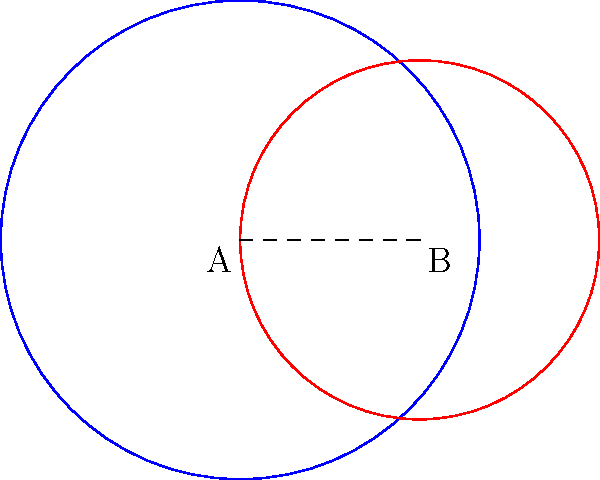Two spotlights are positioned on a stage, represented by circles A and B in the diagram. Spotlight A has a radius of 4 meters, and spotlight B has a radius of 3 meters. The centers of the spotlights are 3 meters apart. What is the area of the overlapping region where both spotlights illuminate the stage? Round your answer to two decimal places. To find the area of overlap between two circles, we need to use the formula for the area of intersection:

1) First, calculate the distance $d$ between the centers:
   $d = 3$ meters (given)

2) Use the formula for the area of intersection:
   $A = r_1^2 \arccos(\frac{d^2 + r_1^2 - r_2^2}{2dr_1}) + r_2^2 \arccos(\frac{d^2 + r_2^2 - r_1^2}{2dr_2}) - \frac{1}{2}\sqrt{(-d+r_1+r_2)(d+r_1-r_2)(d-r_1+r_2)(d+r_1+r_2)}$

   Where $r_1 = 4$ and $r_2 = 3$

3) Substitute the values:
   $A = 4^2 \arccos(\frac{3^2 + 4^2 - 3^2}{2 \cdot 3 \cdot 4}) + 3^2 \arccos(\frac{3^2 + 3^2 - 4^2}{2 \cdot 3 \cdot 3}) - \frac{1}{2}\sqrt{(-3+4+3)(3+4-3)(3-4+3)(3+4+3)}$

4) Calculate:
   $A \approx 16 \cdot 0.6435 + 9 \cdot 1.2490 - \frac{1}{2} \cdot 5.1962$
   $A \approx 10.2960 + 11.2410 - 2.5981$
   $A \approx 18.9389$

5) Round to two decimal places:
   $A \approx 18.94$ square meters
Answer: 18.94 square meters 